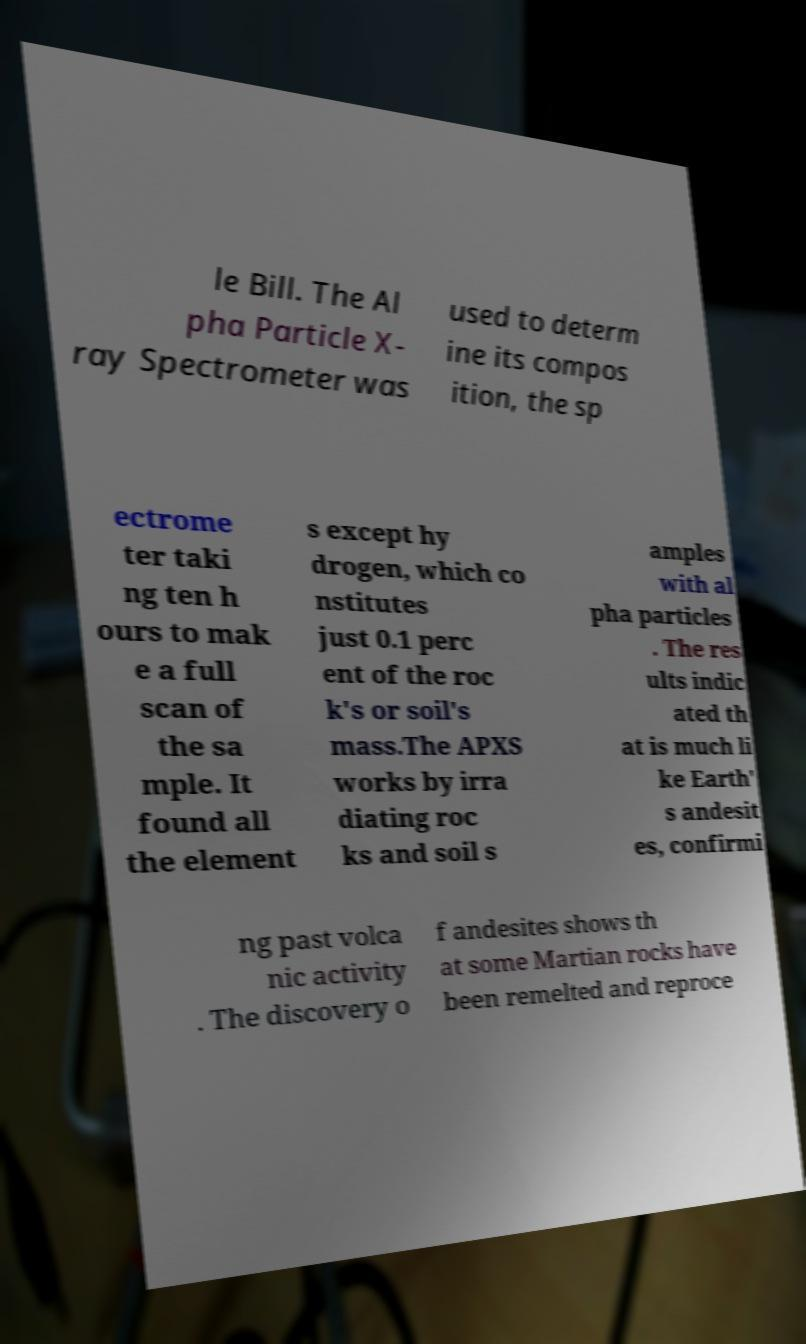Could you extract and type out the text from this image? le Bill. The Al pha Particle X- ray Spectrometer was used to determ ine its compos ition, the sp ectrome ter taki ng ten h ours to mak e a full scan of the sa mple. It found all the element s except hy drogen, which co nstitutes just 0.1 perc ent of the roc k's or soil's mass.The APXS works by irra diating roc ks and soil s amples with al pha particles . The res ults indic ated th at is much li ke Earth' s andesit es, confirmi ng past volca nic activity . The discovery o f andesites shows th at some Martian rocks have been remelted and reproce 